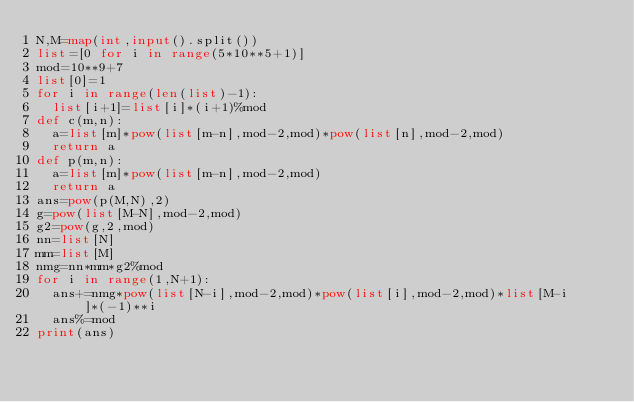<code> <loc_0><loc_0><loc_500><loc_500><_Python_>N,M=map(int,input().split())
list=[0 for i in range(5*10**5+1)]
mod=10**9+7
list[0]=1
for i in range(len(list)-1):
  list[i+1]=list[i]*(i+1)%mod
def c(m,n):
  a=list[m]*pow(list[m-n],mod-2,mod)*pow(list[n],mod-2,mod)
  return a
def p(m,n):
  a=list[m]*pow(list[m-n],mod-2,mod)
  return a
ans=pow(p(M,N),2)
g=pow(list[M-N],mod-2,mod)
g2=pow(g,2,mod)
nn=list[N]
mm=list[M]
nmg=nn*mm*g2%mod
for i in range(1,N+1):
  ans+=nmg*pow(list[N-i],mod-2,mod)*pow(list[i],mod-2,mod)*list[M-i]*(-1)**i
  ans%=mod
print(ans)
</code> 